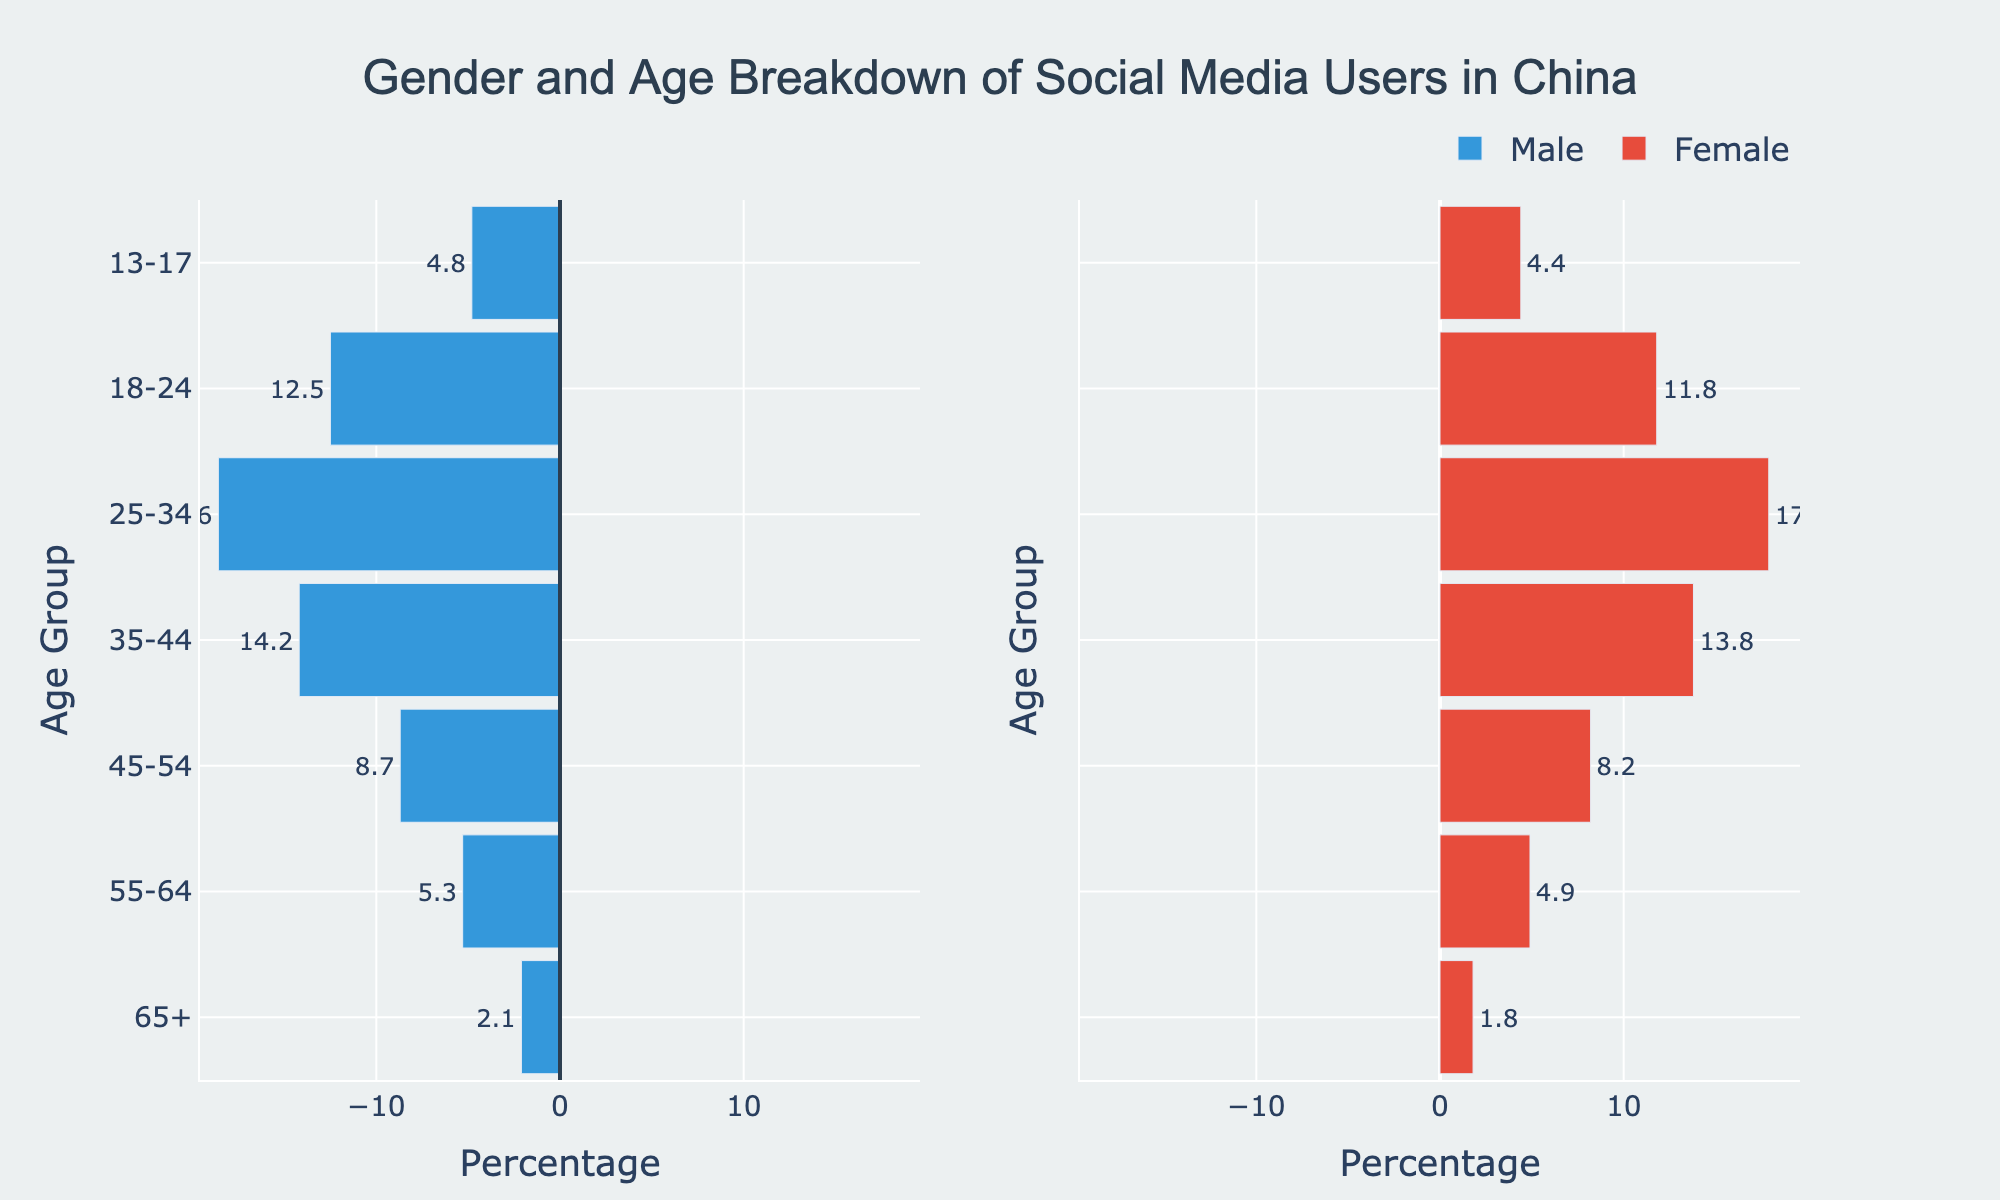What is the title of the figure? The title is typically displayed prominently at the top of the figure. In this case, the title reads "Gender and Age Breakdown of Social Media Users in China". This information can be directly read from the figure.
Answer: Gender and Age Breakdown of Social Media Users in China What age group has the highest percentage of male social media users? To find the age group with the highest percentage of male social media users, we look at the lengths of the bars representing males. The longest bar corresponds to the 25-34 age group with a value of 18.6%.
Answer: 25-34 Which gender has a higher percentage of social media users in the 45-54 age group? By comparing the lengths of the bars for the 45-54 age group, we see that males have an 8.7% representation, whereas females have an 8.2% representation. Thus, males have a higher percentage in this group.
Answer: Males What is the total percentage of social media users in the 18-24 age group for both males and females combined? To find the total percentage for the 18-24 age group, we add the percentages for males and females. Males are 12.5%, and females are 11.8%, so the total is 12.5% + 11.8% = 24.3%.
Answer: 24.3% In which age group is the percentage of female social media users closest to 5%? By inspecting the lengths of the bars for females, the 55-64 age group has a percentage closest to 5% with a value of 4.9%.
Answer: 55-64 How does the percentage of male social media users in the 13-17 age group compare to the percentage of female users in the same group? For the 13-17 age group, males have a 4.8% representation, whereas females have a 4.4% representation. Therefore, males have a slightly higher percentage than females.
Answer: Males have a higher percentage Which age group has the smallest gender gap in social media usage, and what is the percentage difference? To determine the smallest gender gap, we calculate the difference between male and female percentages for each age group. The smallest difference is in the 35-44 age group, where males are 14.2% and females are 13.8%, resulting in a difference of 0.4%.
Answer: 35-44, 0.4% What is the average percentage of male social media users across all age groups? To find the average, sum the male percentages and divide by the number of age groups. (2.1 + 5.3 + 8.7 + 14.2 + 18.6 + 12.5 + 4.8) / 7 = 9.457% (rounded to three decimal places).
Answer: 9.457% Which age group shows the highest percentage of social media users combined (male and female together)? By adding the male and female percentages for all age groups, the 25-34 age group has the highest combined percentage with 18.6% (male) + 17.9% (female) = 36.5%.
Answer: 25-34 How does the social media usage trend vary between genders as age increases from 13-17 to 65+? To understand the trend, observe the bar lengths for both genders across age groups. For males, the percentage generally peaks at 25-34 and decreases towards 65+. For females, the pattern is similar but with slightly more consistent decline post the peak.
Answer: Both genders peak at 25-34 and then decrease 